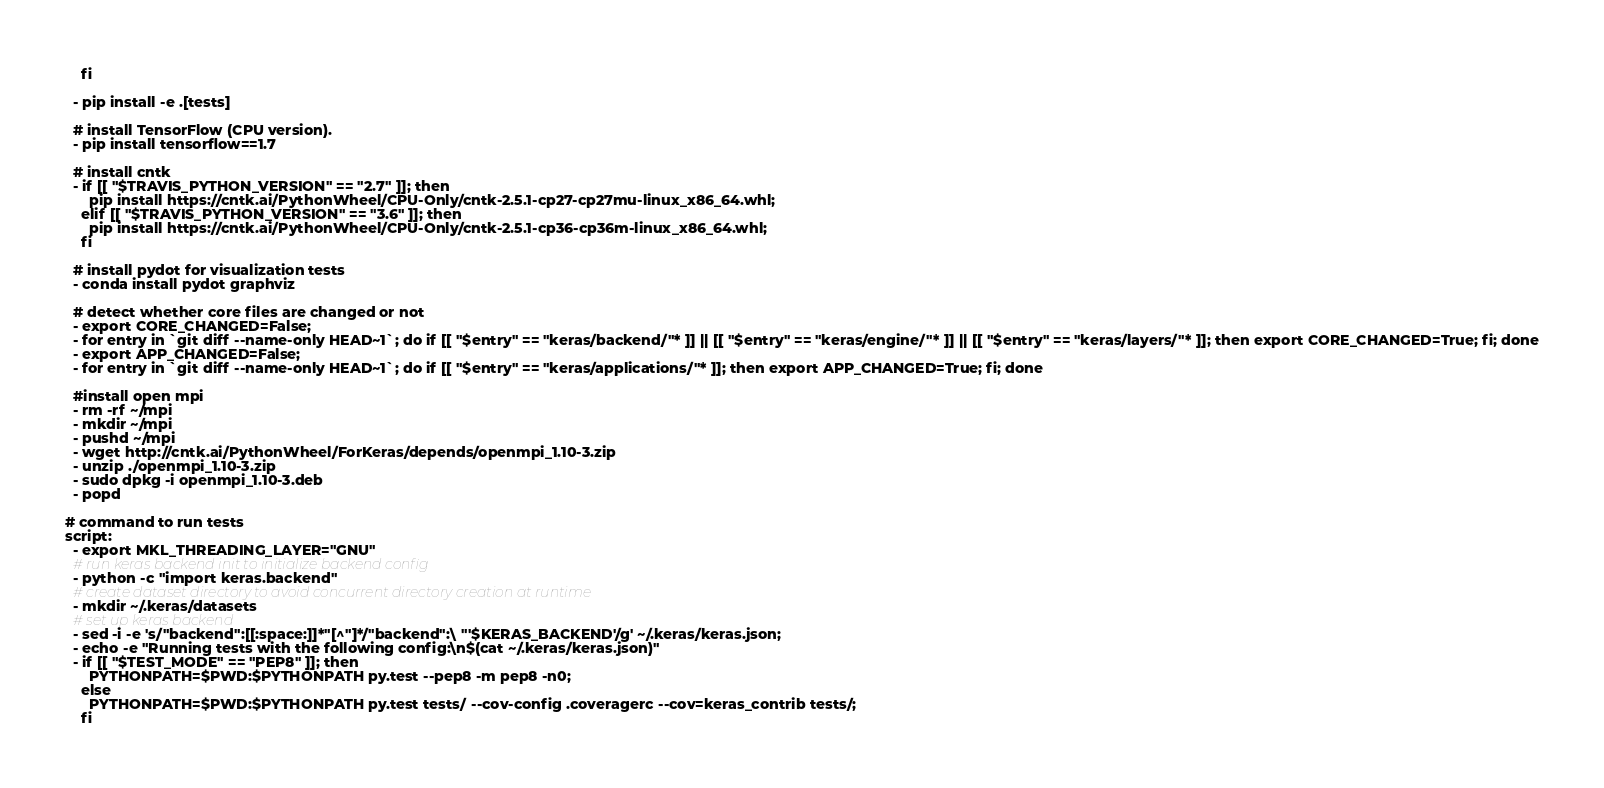Convert code to text. <code><loc_0><loc_0><loc_500><loc_500><_YAML_>    fi

  - pip install -e .[tests]

  # install TensorFlow (CPU version).
  - pip install tensorflow==1.7

  # install cntk
  - if [[ "$TRAVIS_PYTHON_VERSION" == "2.7" ]]; then
      pip install https://cntk.ai/PythonWheel/CPU-Only/cntk-2.5.1-cp27-cp27mu-linux_x86_64.whl;
    elif [[ "$TRAVIS_PYTHON_VERSION" == "3.6" ]]; then
      pip install https://cntk.ai/PythonWheel/CPU-Only/cntk-2.5.1-cp36-cp36m-linux_x86_64.whl;
    fi

  # install pydot for visualization tests
  - conda install pydot graphviz

  # detect whether core files are changed or not
  - export CORE_CHANGED=False;
  - for entry in `git diff --name-only HEAD~1`; do if [[ "$entry" == "keras/backend/"* ]] || [[ "$entry" == "keras/engine/"* ]] || [[ "$entry" == "keras/layers/"* ]]; then export CORE_CHANGED=True; fi; done
  - export APP_CHANGED=False;
  - for entry in `git diff --name-only HEAD~1`; do if [[ "$entry" == "keras/applications/"* ]]; then export APP_CHANGED=True; fi; done

  #install open mpi
  - rm -rf ~/mpi
  - mkdir ~/mpi
  - pushd ~/mpi
  - wget http://cntk.ai/PythonWheel/ForKeras/depends/openmpi_1.10-3.zip
  - unzip ./openmpi_1.10-3.zip
  - sudo dpkg -i openmpi_1.10-3.deb
  - popd

# command to run tests
script:
  - export MKL_THREADING_LAYER="GNU"
  # run keras backend init to initialize backend config
  - python -c "import keras.backend"
  # create dataset directory to avoid concurrent directory creation at runtime
  - mkdir ~/.keras/datasets
  # set up keras backend
  - sed -i -e 's/"backend":[[:space:]]*"[^"]*/"backend":\ "'$KERAS_BACKEND'/g' ~/.keras/keras.json;
  - echo -e "Running tests with the following config:\n$(cat ~/.keras/keras.json)"
  - if [[ "$TEST_MODE" == "PEP8" ]]; then
      PYTHONPATH=$PWD:$PYTHONPATH py.test --pep8 -m pep8 -n0;
    else
      PYTHONPATH=$PWD:$PYTHONPATH py.test tests/ --cov-config .coveragerc --cov=keras_contrib tests/;
    fi
</code> 